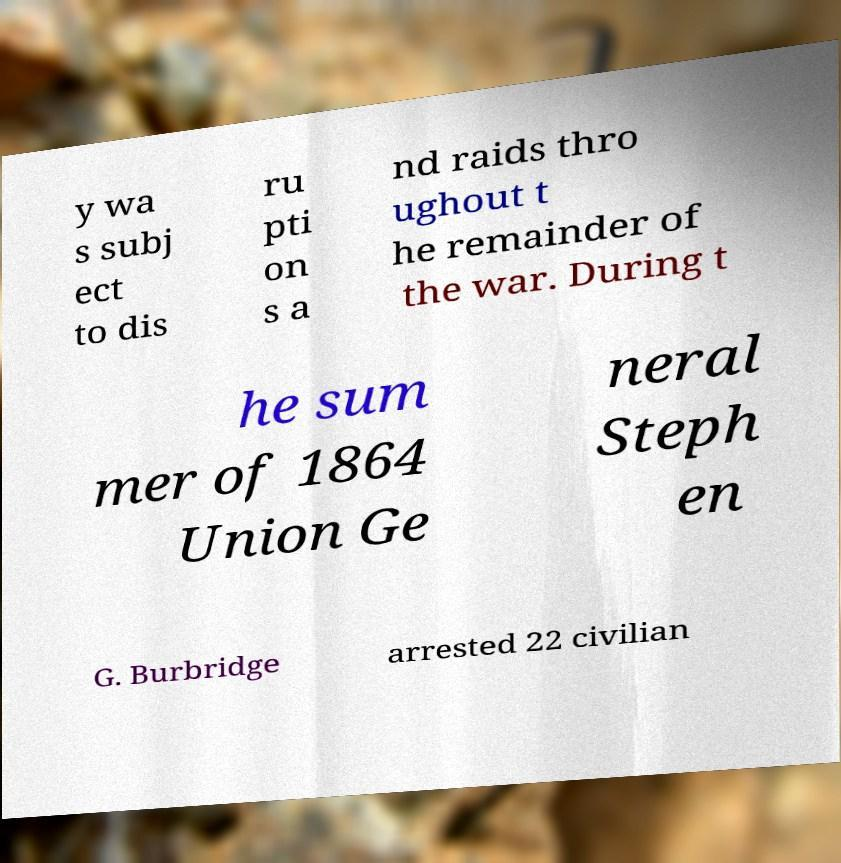What messages or text are displayed in this image? I need them in a readable, typed format. y wa s subj ect to dis ru pti on s a nd raids thro ughout t he remainder of the war. During t he sum mer of 1864 Union Ge neral Steph en G. Burbridge arrested 22 civilian 